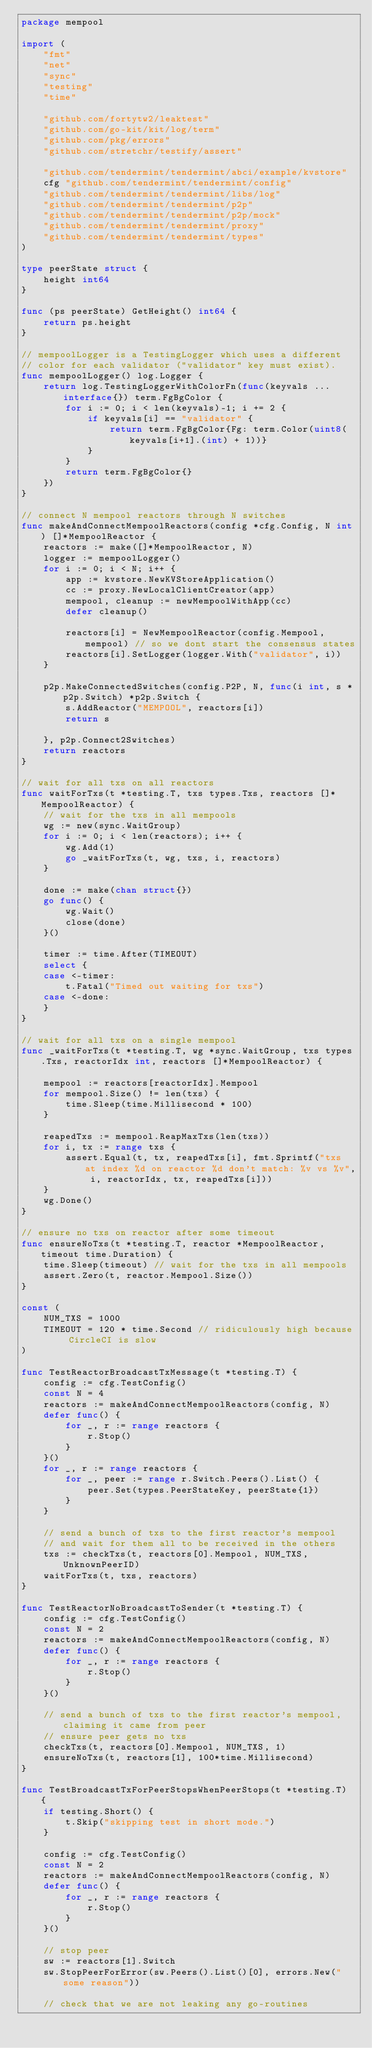Convert code to text. <code><loc_0><loc_0><loc_500><loc_500><_Go_>package mempool

import (
	"fmt"
	"net"
	"sync"
	"testing"
	"time"

	"github.com/fortytw2/leaktest"
	"github.com/go-kit/kit/log/term"
	"github.com/pkg/errors"
	"github.com/stretchr/testify/assert"

	"github.com/tendermint/tendermint/abci/example/kvstore"
	cfg "github.com/tendermint/tendermint/config"
	"github.com/tendermint/tendermint/libs/log"
	"github.com/tendermint/tendermint/p2p"
	"github.com/tendermint/tendermint/p2p/mock"
	"github.com/tendermint/tendermint/proxy"
	"github.com/tendermint/tendermint/types"
)

type peerState struct {
	height int64
}

func (ps peerState) GetHeight() int64 {
	return ps.height
}

// mempoolLogger is a TestingLogger which uses a different
// color for each validator ("validator" key must exist).
func mempoolLogger() log.Logger {
	return log.TestingLoggerWithColorFn(func(keyvals ...interface{}) term.FgBgColor {
		for i := 0; i < len(keyvals)-1; i += 2 {
			if keyvals[i] == "validator" {
				return term.FgBgColor{Fg: term.Color(uint8(keyvals[i+1].(int) + 1))}
			}
		}
		return term.FgBgColor{}
	})
}

// connect N mempool reactors through N switches
func makeAndConnectMempoolReactors(config *cfg.Config, N int) []*MempoolReactor {
	reactors := make([]*MempoolReactor, N)
	logger := mempoolLogger()
	for i := 0; i < N; i++ {
		app := kvstore.NewKVStoreApplication()
		cc := proxy.NewLocalClientCreator(app)
		mempool, cleanup := newMempoolWithApp(cc)
		defer cleanup()

		reactors[i] = NewMempoolReactor(config.Mempool, mempool) // so we dont start the consensus states
		reactors[i].SetLogger(logger.With("validator", i))
	}

	p2p.MakeConnectedSwitches(config.P2P, N, func(i int, s *p2p.Switch) *p2p.Switch {
		s.AddReactor("MEMPOOL", reactors[i])
		return s

	}, p2p.Connect2Switches)
	return reactors
}

// wait for all txs on all reactors
func waitForTxs(t *testing.T, txs types.Txs, reactors []*MempoolReactor) {
	// wait for the txs in all mempools
	wg := new(sync.WaitGroup)
	for i := 0; i < len(reactors); i++ {
		wg.Add(1)
		go _waitForTxs(t, wg, txs, i, reactors)
	}

	done := make(chan struct{})
	go func() {
		wg.Wait()
		close(done)
	}()

	timer := time.After(TIMEOUT)
	select {
	case <-timer:
		t.Fatal("Timed out waiting for txs")
	case <-done:
	}
}

// wait for all txs on a single mempool
func _waitForTxs(t *testing.T, wg *sync.WaitGroup, txs types.Txs, reactorIdx int, reactors []*MempoolReactor) {

	mempool := reactors[reactorIdx].Mempool
	for mempool.Size() != len(txs) {
		time.Sleep(time.Millisecond * 100)
	}

	reapedTxs := mempool.ReapMaxTxs(len(txs))
	for i, tx := range txs {
		assert.Equal(t, tx, reapedTxs[i], fmt.Sprintf("txs at index %d on reactor %d don't match: %v vs %v", i, reactorIdx, tx, reapedTxs[i]))
	}
	wg.Done()
}

// ensure no txs on reactor after some timeout
func ensureNoTxs(t *testing.T, reactor *MempoolReactor, timeout time.Duration) {
	time.Sleep(timeout) // wait for the txs in all mempools
	assert.Zero(t, reactor.Mempool.Size())
}

const (
	NUM_TXS = 1000
	TIMEOUT = 120 * time.Second // ridiculously high because CircleCI is slow
)

func TestReactorBroadcastTxMessage(t *testing.T) {
	config := cfg.TestConfig()
	const N = 4
	reactors := makeAndConnectMempoolReactors(config, N)
	defer func() {
		for _, r := range reactors {
			r.Stop()
		}
	}()
	for _, r := range reactors {
		for _, peer := range r.Switch.Peers().List() {
			peer.Set(types.PeerStateKey, peerState{1})
		}
	}

	// send a bunch of txs to the first reactor's mempool
	// and wait for them all to be received in the others
	txs := checkTxs(t, reactors[0].Mempool, NUM_TXS, UnknownPeerID)
	waitForTxs(t, txs, reactors)
}

func TestReactorNoBroadcastToSender(t *testing.T) {
	config := cfg.TestConfig()
	const N = 2
	reactors := makeAndConnectMempoolReactors(config, N)
	defer func() {
		for _, r := range reactors {
			r.Stop()
		}
	}()

	// send a bunch of txs to the first reactor's mempool, claiming it came from peer
	// ensure peer gets no txs
	checkTxs(t, reactors[0].Mempool, NUM_TXS, 1)
	ensureNoTxs(t, reactors[1], 100*time.Millisecond)
}

func TestBroadcastTxForPeerStopsWhenPeerStops(t *testing.T) {
	if testing.Short() {
		t.Skip("skipping test in short mode.")
	}

	config := cfg.TestConfig()
	const N = 2
	reactors := makeAndConnectMempoolReactors(config, N)
	defer func() {
		for _, r := range reactors {
			r.Stop()
		}
	}()

	// stop peer
	sw := reactors[1].Switch
	sw.StopPeerForError(sw.Peers().List()[0], errors.New("some reason"))

	// check that we are not leaking any go-routines</code> 